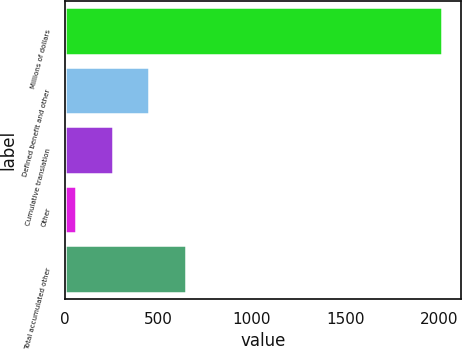Convert chart. <chart><loc_0><loc_0><loc_500><loc_500><bar_chart><fcel>Millions of dollars<fcel>Defined benefit and other<fcel>Cumulative translation<fcel>Other<fcel>Total accumulated other<nl><fcel>2016<fcel>452<fcel>256.5<fcel>61<fcel>647.5<nl></chart> 